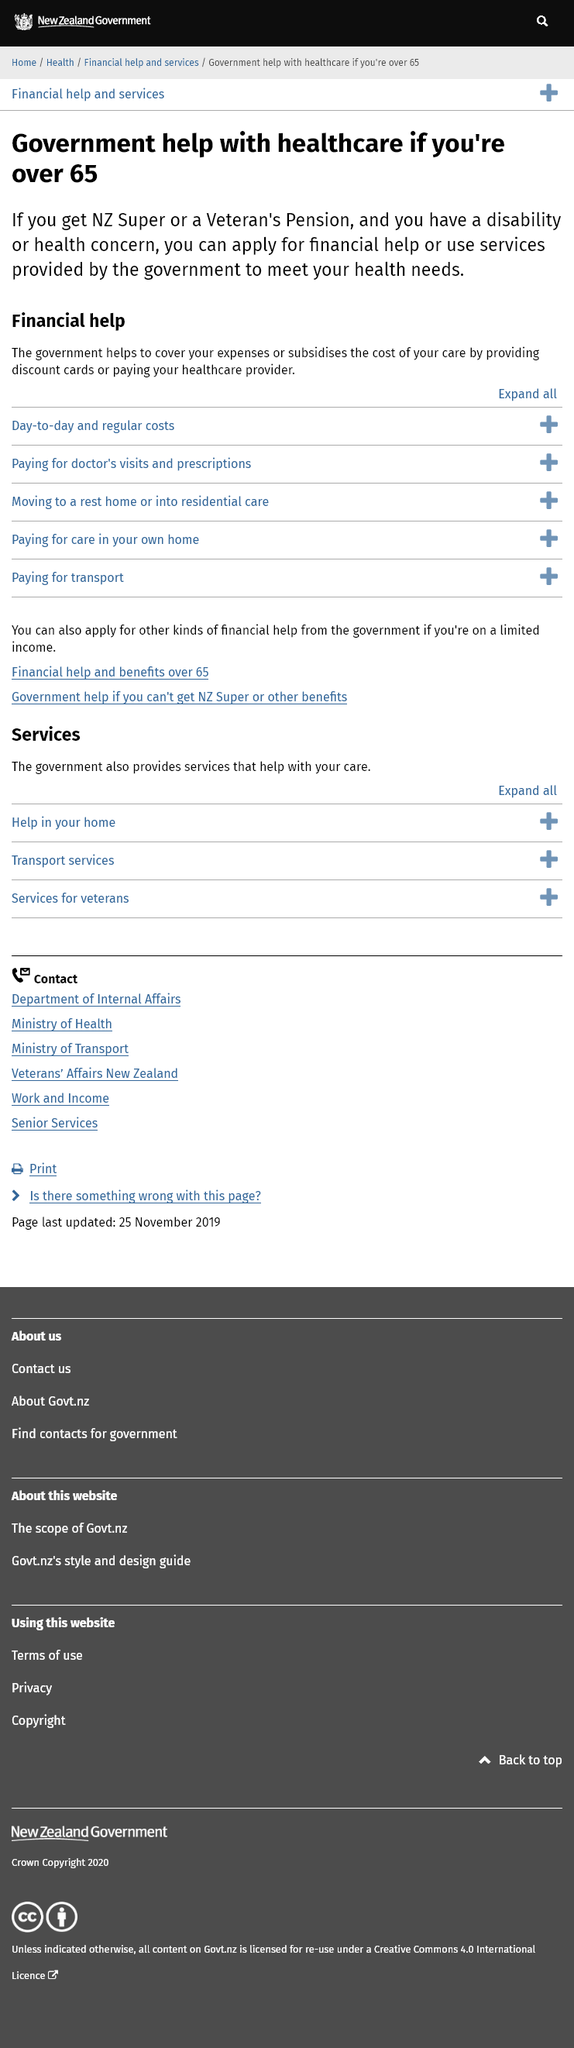Point out several critical features in this image. The government can assist in covering the cost of healthcare providers or provide discount cards to individuals for healthcare expenses. If you are receiving NZ Super or a Veteran's Pension and have a disability or health concern, you are entitled to apply for financial assistance to treat that concern. The government will provide healthcare assistance to individuals who are over 65 years old and have a disability. 